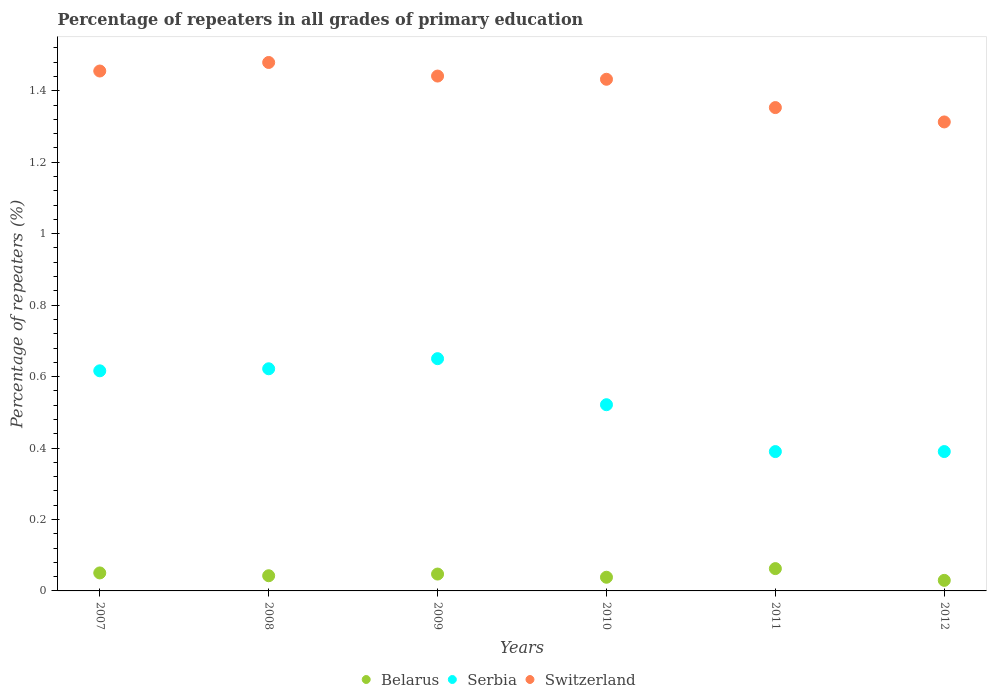Is the number of dotlines equal to the number of legend labels?
Ensure brevity in your answer.  Yes. What is the percentage of repeaters in Belarus in 2008?
Make the answer very short. 0.04. Across all years, what is the maximum percentage of repeaters in Switzerland?
Offer a very short reply. 1.48. Across all years, what is the minimum percentage of repeaters in Serbia?
Your response must be concise. 0.39. In which year was the percentage of repeaters in Serbia minimum?
Give a very brief answer. 2011. What is the total percentage of repeaters in Serbia in the graph?
Ensure brevity in your answer.  3.19. What is the difference between the percentage of repeaters in Serbia in 2009 and that in 2010?
Offer a very short reply. 0.13. What is the difference between the percentage of repeaters in Switzerland in 2009 and the percentage of repeaters in Serbia in 2008?
Offer a very short reply. 0.82. What is the average percentage of repeaters in Switzerland per year?
Ensure brevity in your answer.  1.41. In the year 2007, what is the difference between the percentage of repeaters in Serbia and percentage of repeaters in Belarus?
Provide a succinct answer. 0.57. What is the ratio of the percentage of repeaters in Belarus in 2009 to that in 2010?
Your answer should be compact. 1.23. What is the difference between the highest and the second highest percentage of repeaters in Switzerland?
Your answer should be very brief. 0.02. What is the difference between the highest and the lowest percentage of repeaters in Belarus?
Your response must be concise. 0.03. In how many years, is the percentage of repeaters in Belarus greater than the average percentage of repeaters in Belarus taken over all years?
Your response must be concise. 3. Is the sum of the percentage of repeaters in Switzerland in 2008 and 2010 greater than the maximum percentage of repeaters in Serbia across all years?
Give a very brief answer. Yes. How many dotlines are there?
Provide a short and direct response. 3. Does the graph contain grids?
Give a very brief answer. No. How many legend labels are there?
Your answer should be very brief. 3. What is the title of the graph?
Provide a succinct answer. Percentage of repeaters in all grades of primary education. Does "Azerbaijan" appear as one of the legend labels in the graph?
Provide a short and direct response. No. What is the label or title of the Y-axis?
Give a very brief answer. Percentage of repeaters (%). What is the Percentage of repeaters (%) in Belarus in 2007?
Give a very brief answer. 0.05. What is the Percentage of repeaters (%) in Serbia in 2007?
Ensure brevity in your answer.  0.62. What is the Percentage of repeaters (%) of Switzerland in 2007?
Provide a succinct answer. 1.46. What is the Percentage of repeaters (%) in Belarus in 2008?
Ensure brevity in your answer.  0.04. What is the Percentage of repeaters (%) of Serbia in 2008?
Provide a succinct answer. 0.62. What is the Percentage of repeaters (%) in Switzerland in 2008?
Your answer should be compact. 1.48. What is the Percentage of repeaters (%) of Belarus in 2009?
Provide a succinct answer. 0.05. What is the Percentage of repeaters (%) of Serbia in 2009?
Keep it short and to the point. 0.65. What is the Percentage of repeaters (%) in Switzerland in 2009?
Your answer should be very brief. 1.44. What is the Percentage of repeaters (%) of Belarus in 2010?
Your answer should be compact. 0.04. What is the Percentage of repeaters (%) of Serbia in 2010?
Keep it short and to the point. 0.52. What is the Percentage of repeaters (%) of Switzerland in 2010?
Offer a terse response. 1.43. What is the Percentage of repeaters (%) of Belarus in 2011?
Provide a succinct answer. 0.06. What is the Percentage of repeaters (%) of Serbia in 2011?
Your answer should be compact. 0.39. What is the Percentage of repeaters (%) in Switzerland in 2011?
Provide a succinct answer. 1.35. What is the Percentage of repeaters (%) in Belarus in 2012?
Ensure brevity in your answer.  0.03. What is the Percentage of repeaters (%) in Serbia in 2012?
Your answer should be very brief. 0.39. What is the Percentage of repeaters (%) in Switzerland in 2012?
Your answer should be very brief. 1.31. Across all years, what is the maximum Percentage of repeaters (%) of Belarus?
Your response must be concise. 0.06. Across all years, what is the maximum Percentage of repeaters (%) of Serbia?
Your answer should be compact. 0.65. Across all years, what is the maximum Percentage of repeaters (%) in Switzerland?
Your response must be concise. 1.48. Across all years, what is the minimum Percentage of repeaters (%) of Belarus?
Your response must be concise. 0.03. Across all years, what is the minimum Percentage of repeaters (%) of Serbia?
Make the answer very short. 0.39. Across all years, what is the minimum Percentage of repeaters (%) in Switzerland?
Your answer should be very brief. 1.31. What is the total Percentage of repeaters (%) of Belarus in the graph?
Provide a short and direct response. 0.27. What is the total Percentage of repeaters (%) of Serbia in the graph?
Offer a very short reply. 3.19. What is the total Percentage of repeaters (%) of Switzerland in the graph?
Your answer should be very brief. 8.47. What is the difference between the Percentage of repeaters (%) of Belarus in 2007 and that in 2008?
Your response must be concise. 0.01. What is the difference between the Percentage of repeaters (%) in Serbia in 2007 and that in 2008?
Give a very brief answer. -0.01. What is the difference between the Percentage of repeaters (%) of Switzerland in 2007 and that in 2008?
Provide a succinct answer. -0.02. What is the difference between the Percentage of repeaters (%) in Belarus in 2007 and that in 2009?
Make the answer very short. 0. What is the difference between the Percentage of repeaters (%) of Serbia in 2007 and that in 2009?
Make the answer very short. -0.03. What is the difference between the Percentage of repeaters (%) in Switzerland in 2007 and that in 2009?
Give a very brief answer. 0.01. What is the difference between the Percentage of repeaters (%) of Belarus in 2007 and that in 2010?
Provide a short and direct response. 0.01. What is the difference between the Percentage of repeaters (%) of Serbia in 2007 and that in 2010?
Your answer should be compact. 0.09. What is the difference between the Percentage of repeaters (%) of Switzerland in 2007 and that in 2010?
Give a very brief answer. 0.02. What is the difference between the Percentage of repeaters (%) of Belarus in 2007 and that in 2011?
Ensure brevity in your answer.  -0.01. What is the difference between the Percentage of repeaters (%) of Serbia in 2007 and that in 2011?
Keep it short and to the point. 0.23. What is the difference between the Percentage of repeaters (%) of Switzerland in 2007 and that in 2011?
Provide a succinct answer. 0.1. What is the difference between the Percentage of repeaters (%) of Belarus in 2007 and that in 2012?
Give a very brief answer. 0.02. What is the difference between the Percentage of repeaters (%) of Serbia in 2007 and that in 2012?
Keep it short and to the point. 0.23. What is the difference between the Percentage of repeaters (%) of Switzerland in 2007 and that in 2012?
Your answer should be very brief. 0.14. What is the difference between the Percentage of repeaters (%) of Belarus in 2008 and that in 2009?
Provide a short and direct response. -0. What is the difference between the Percentage of repeaters (%) of Serbia in 2008 and that in 2009?
Give a very brief answer. -0.03. What is the difference between the Percentage of repeaters (%) in Switzerland in 2008 and that in 2009?
Your answer should be very brief. 0.04. What is the difference between the Percentage of repeaters (%) of Belarus in 2008 and that in 2010?
Your response must be concise. 0. What is the difference between the Percentage of repeaters (%) of Serbia in 2008 and that in 2010?
Keep it short and to the point. 0.1. What is the difference between the Percentage of repeaters (%) in Switzerland in 2008 and that in 2010?
Ensure brevity in your answer.  0.05. What is the difference between the Percentage of repeaters (%) in Belarus in 2008 and that in 2011?
Offer a terse response. -0.02. What is the difference between the Percentage of repeaters (%) in Serbia in 2008 and that in 2011?
Provide a succinct answer. 0.23. What is the difference between the Percentage of repeaters (%) in Switzerland in 2008 and that in 2011?
Give a very brief answer. 0.13. What is the difference between the Percentage of repeaters (%) in Belarus in 2008 and that in 2012?
Provide a short and direct response. 0.01. What is the difference between the Percentage of repeaters (%) in Serbia in 2008 and that in 2012?
Provide a succinct answer. 0.23. What is the difference between the Percentage of repeaters (%) in Switzerland in 2008 and that in 2012?
Your response must be concise. 0.17. What is the difference between the Percentage of repeaters (%) in Belarus in 2009 and that in 2010?
Provide a short and direct response. 0.01. What is the difference between the Percentage of repeaters (%) in Serbia in 2009 and that in 2010?
Your answer should be very brief. 0.13. What is the difference between the Percentage of repeaters (%) in Switzerland in 2009 and that in 2010?
Keep it short and to the point. 0.01. What is the difference between the Percentage of repeaters (%) of Belarus in 2009 and that in 2011?
Provide a succinct answer. -0.02. What is the difference between the Percentage of repeaters (%) of Serbia in 2009 and that in 2011?
Your response must be concise. 0.26. What is the difference between the Percentage of repeaters (%) in Switzerland in 2009 and that in 2011?
Give a very brief answer. 0.09. What is the difference between the Percentage of repeaters (%) of Belarus in 2009 and that in 2012?
Ensure brevity in your answer.  0.02. What is the difference between the Percentage of repeaters (%) in Serbia in 2009 and that in 2012?
Provide a succinct answer. 0.26. What is the difference between the Percentage of repeaters (%) of Switzerland in 2009 and that in 2012?
Your answer should be compact. 0.13. What is the difference between the Percentage of repeaters (%) in Belarus in 2010 and that in 2011?
Offer a very short reply. -0.02. What is the difference between the Percentage of repeaters (%) in Serbia in 2010 and that in 2011?
Offer a terse response. 0.13. What is the difference between the Percentage of repeaters (%) in Switzerland in 2010 and that in 2011?
Your answer should be compact. 0.08. What is the difference between the Percentage of repeaters (%) in Belarus in 2010 and that in 2012?
Make the answer very short. 0.01. What is the difference between the Percentage of repeaters (%) of Serbia in 2010 and that in 2012?
Your response must be concise. 0.13. What is the difference between the Percentage of repeaters (%) of Switzerland in 2010 and that in 2012?
Offer a very short reply. 0.12. What is the difference between the Percentage of repeaters (%) in Belarus in 2011 and that in 2012?
Offer a very short reply. 0.03. What is the difference between the Percentage of repeaters (%) of Serbia in 2011 and that in 2012?
Your answer should be compact. -0. What is the difference between the Percentage of repeaters (%) of Switzerland in 2011 and that in 2012?
Ensure brevity in your answer.  0.04. What is the difference between the Percentage of repeaters (%) in Belarus in 2007 and the Percentage of repeaters (%) in Serbia in 2008?
Your answer should be very brief. -0.57. What is the difference between the Percentage of repeaters (%) in Belarus in 2007 and the Percentage of repeaters (%) in Switzerland in 2008?
Keep it short and to the point. -1.43. What is the difference between the Percentage of repeaters (%) of Serbia in 2007 and the Percentage of repeaters (%) of Switzerland in 2008?
Offer a terse response. -0.86. What is the difference between the Percentage of repeaters (%) of Belarus in 2007 and the Percentage of repeaters (%) of Serbia in 2009?
Offer a very short reply. -0.6. What is the difference between the Percentage of repeaters (%) of Belarus in 2007 and the Percentage of repeaters (%) of Switzerland in 2009?
Provide a short and direct response. -1.39. What is the difference between the Percentage of repeaters (%) of Serbia in 2007 and the Percentage of repeaters (%) of Switzerland in 2009?
Your answer should be very brief. -0.83. What is the difference between the Percentage of repeaters (%) of Belarus in 2007 and the Percentage of repeaters (%) of Serbia in 2010?
Your answer should be compact. -0.47. What is the difference between the Percentage of repeaters (%) of Belarus in 2007 and the Percentage of repeaters (%) of Switzerland in 2010?
Your answer should be very brief. -1.38. What is the difference between the Percentage of repeaters (%) in Serbia in 2007 and the Percentage of repeaters (%) in Switzerland in 2010?
Your answer should be very brief. -0.82. What is the difference between the Percentage of repeaters (%) in Belarus in 2007 and the Percentage of repeaters (%) in Serbia in 2011?
Your response must be concise. -0.34. What is the difference between the Percentage of repeaters (%) of Belarus in 2007 and the Percentage of repeaters (%) of Switzerland in 2011?
Your answer should be compact. -1.3. What is the difference between the Percentage of repeaters (%) in Serbia in 2007 and the Percentage of repeaters (%) in Switzerland in 2011?
Your answer should be compact. -0.74. What is the difference between the Percentage of repeaters (%) in Belarus in 2007 and the Percentage of repeaters (%) in Serbia in 2012?
Offer a terse response. -0.34. What is the difference between the Percentage of repeaters (%) in Belarus in 2007 and the Percentage of repeaters (%) in Switzerland in 2012?
Ensure brevity in your answer.  -1.26. What is the difference between the Percentage of repeaters (%) in Serbia in 2007 and the Percentage of repeaters (%) in Switzerland in 2012?
Offer a terse response. -0.7. What is the difference between the Percentage of repeaters (%) of Belarus in 2008 and the Percentage of repeaters (%) of Serbia in 2009?
Keep it short and to the point. -0.61. What is the difference between the Percentage of repeaters (%) in Belarus in 2008 and the Percentage of repeaters (%) in Switzerland in 2009?
Ensure brevity in your answer.  -1.4. What is the difference between the Percentage of repeaters (%) in Serbia in 2008 and the Percentage of repeaters (%) in Switzerland in 2009?
Your answer should be compact. -0.82. What is the difference between the Percentage of repeaters (%) in Belarus in 2008 and the Percentage of repeaters (%) in Serbia in 2010?
Give a very brief answer. -0.48. What is the difference between the Percentage of repeaters (%) in Belarus in 2008 and the Percentage of repeaters (%) in Switzerland in 2010?
Offer a very short reply. -1.39. What is the difference between the Percentage of repeaters (%) in Serbia in 2008 and the Percentage of repeaters (%) in Switzerland in 2010?
Your answer should be very brief. -0.81. What is the difference between the Percentage of repeaters (%) in Belarus in 2008 and the Percentage of repeaters (%) in Serbia in 2011?
Your response must be concise. -0.35. What is the difference between the Percentage of repeaters (%) in Belarus in 2008 and the Percentage of repeaters (%) in Switzerland in 2011?
Offer a terse response. -1.31. What is the difference between the Percentage of repeaters (%) of Serbia in 2008 and the Percentage of repeaters (%) of Switzerland in 2011?
Make the answer very short. -0.73. What is the difference between the Percentage of repeaters (%) in Belarus in 2008 and the Percentage of repeaters (%) in Serbia in 2012?
Provide a succinct answer. -0.35. What is the difference between the Percentage of repeaters (%) of Belarus in 2008 and the Percentage of repeaters (%) of Switzerland in 2012?
Keep it short and to the point. -1.27. What is the difference between the Percentage of repeaters (%) of Serbia in 2008 and the Percentage of repeaters (%) of Switzerland in 2012?
Provide a succinct answer. -0.69. What is the difference between the Percentage of repeaters (%) in Belarus in 2009 and the Percentage of repeaters (%) in Serbia in 2010?
Make the answer very short. -0.47. What is the difference between the Percentage of repeaters (%) in Belarus in 2009 and the Percentage of repeaters (%) in Switzerland in 2010?
Make the answer very short. -1.39. What is the difference between the Percentage of repeaters (%) of Serbia in 2009 and the Percentage of repeaters (%) of Switzerland in 2010?
Your answer should be very brief. -0.78. What is the difference between the Percentage of repeaters (%) of Belarus in 2009 and the Percentage of repeaters (%) of Serbia in 2011?
Keep it short and to the point. -0.34. What is the difference between the Percentage of repeaters (%) in Belarus in 2009 and the Percentage of repeaters (%) in Switzerland in 2011?
Your response must be concise. -1.31. What is the difference between the Percentage of repeaters (%) in Serbia in 2009 and the Percentage of repeaters (%) in Switzerland in 2011?
Provide a short and direct response. -0.7. What is the difference between the Percentage of repeaters (%) in Belarus in 2009 and the Percentage of repeaters (%) in Serbia in 2012?
Provide a succinct answer. -0.34. What is the difference between the Percentage of repeaters (%) in Belarus in 2009 and the Percentage of repeaters (%) in Switzerland in 2012?
Give a very brief answer. -1.27. What is the difference between the Percentage of repeaters (%) in Serbia in 2009 and the Percentage of repeaters (%) in Switzerland in 2012?
Make the answer very short. -0.66. What is the difference between the Percentage of repeaters (%) of Belarus in 2010 and the Percentage of repeaters (%) of Serbia in 2011?
Make the answer very short. -0.35. What is the difference between the Percentage of repeaters (%) in Belarus in 2010 and the Percentage of repeaters (%) in Switzerland in 2011?
Give a very brief answer. -1.31. What is the difference between the Percentage of repeaters (%) in Serbia in 2010 and the Percentage of repeaters (%) in Switzerland in 2011?
Give a very brief answer. -0.83. What is the difference between the Percentage of repeaters (%) of Belarus in 2010 and the Percentage of repeaters (%) of Serbia in 2012?
Offer a terse response. -0.35. What is the difference between the Percentage of repeaters (%) of Belarus in 2010 and the Percentage of repeaters (%) of Switzerland in 2012?
Offer a terse response. -1.27. What is the difference between the Percentage of repeaters (%) in Serbia in 2010 and the Percentage of repeaters (%) in Switzerland in 2012?
Make the answer very short. -0.79. What is the difference between the Percentage of repeaters (%) in Belarus in 2011 and the Percentage of repeaters (%) in Serbia in 2012?
Make the answer very short. -0.33. What is the difference between the Percentage of repeaters (%) in Belarus in 2011 and the Percentage of repeaters (%) in Switzerland in 2012?
Your response must be concise. -1.25. What is the difference between the Percentage of repeaters (%) in Serbia in 2011 and the Percentage of repeaters (%) in Switzerland in 2012?
Give a very brief answer. -0.92. What is the average Percentage of repeaters (%) in Belarus per year?
Provide a succinct answer. 0.05. What is the average Percentage of repeaters (%) in Serbia per year?
Give a very brief answer. 0.53. What is the average Percentage of repeaters (%) in Switzerland per year?
Keep it short and to the point. 1.41. In the year 2007, what is the difference between the Percentage of repeaters (%) in Belarus and Percentage of repeaters (%) in Serbia?
Your response must be concise. -0.57. In the year 2007, what is the difference between the Percentage of repeaters (%) in Belarus and Percentage of repeaters (%) in Switzerland?
Your answer should be compact. -1.41. In the year 2007, what is the difference between the Percentage of repeaters (%) in Serbia and Percentage of repeaters (%) in Switzerland?
Your answer should be compact. -0.84. In the year 2008, what is the difference between the Percentage of repeaters (%) in Belarus and Percentage of repeaters (%) in Serbia?
Ensure brevity in your answer.  -0.58. In the year 2008, what is the difference between the Percentage of repeaters (%) in Belarus and Percentage of repeaters (%) in Switzerland?
Your answer should be very brief. -1.44. In the year 2008, what is the difference between the Percentage of repeaters (%) in Serbia and Percentage of repeaters (%) in Switzerland?
Provide a succinct answer. -0.86. In the year 2009, what is the difference between the Percentage of repeaters (%) in Belarus and Percentage of repeaters (%) in Serbia?
Offer a very short reply. -0.6. In the year 2009, what is the difference between the Percentage of repeaters (%) in Belarus and Percentage of repeaters (%) in Switzerland?
Your answer should be compact. -1.39. In the year 2009, what is the difference between the Percentage of repeaters (%) of Serbia and Percentage of repeaters (%) of Switzerland?
Provide a short and direct response. -0.79. In the year 2010, what is the difference between the Percentage of repeaters (%) in Belarus and Percentage of repeaters (%) in Serbia?
Offer a very short reply. -0.48. In the year 2010, what is the difference between the Percentage of repeaters (%) in Belarus and Percentage of repeaters (%) in Switzerland?
Provide a short and direct response. -1.39. In the year 2010, what is the difference between the Percentage of repeaters (%) in Serbia and Percentage of repeaters (%) in Switzerland?
Give a very brief answer. -0.91. In the year 2011, what is the difference between the Percentage of repeaters (%) of Belarus and Percentage of repeaters (%) of Serbia?
Provide a succinct answer. -0.33. In the year 2011, what is the difference between the Percentage of repeaters (%) in Belarus and Percentage of repeaters (%) in Switzerland?
Your answer should be very brief. -1.29. In the year 2011, what is the difference between the Percentage of repeaters (%) of Serbia and Percentage of repeaters (%) of Switzerland?
Ensure brevity in your answer.  -0.96. In the year 2012, what is the difference between the Percentage of repeaters (%) in Belarus and Percentage of repeaters (%) in Serbia?
Offer a very short reply. -0.36. In the year 2012, what is the difference between the Percentage of repeaters (%) of Belarus and Percentage of repeaters (%) of Switzerland?
Your answer should be very brief. -1.28. In the year 2012, what is the difference between the Percentage of repeaters (%) of Serbia and Percentage of repeaters (%) of Switzerland?
Provide a succinct answer. -0.92. What is the ratio of the Percentage of repeaters (%) in Belarus in 2007 to that in 2008?
Your response must be concise. 1.18. What is the ratio of the Percentage of repeaters (%) in Switzerland in 2007 to that in 2008?
Provide a succinct answer. 0.98. What is the ratio of the Percentage of repeaters (%) in Belarus in 2007 to that in 2009?
Ensure brevity in your answer.  1.07. What is the ratio of the Percentage of repeaters (%) in Serbia in 2007 to that in 2009?
Provide a short and direct response. 0.95. What is the ratio of the Percentage of repeaters (%) of Switzerland in 2007 to that in 2009?
Provide a succinct answer. 1.01. What is the ratio of the Percentage of repeaters (%) in Belarus in 2007 to that in 2010?
Your answer should be very brief. 1.31. What is the ratio of the Percentage of repeaters (%) in Serbia in 2007 to that in 2010?
Offer a very short reply. 1.18. What is the ratio of the Percentage of repeaters (%) in Switzerland in 2007 to that in 2010?
Keep it short and to the point. 1.02. What is the ratio of the Percentage of repeaters (%) in Belarus in 2007 to that in 2011?
Offer a terse response. 0.81. What is the ratio of the Percentage of repeaters (%) of Serbia in 2007 to that in 2011?
Your answer should be very brief. 1.58. What is the ratio of the Percentage of repeaters (%) in Switzerland in 2007 to that in 2011?
Your answer should be compact. 1.08. What is the ratio of the Percentage of repeaters (%) of Belarus in 2007 to that in 2012?
Your response must be concise. 1.7. What is the ratio of the Percentage of repeaters (%) of Serbia in 2007 to that in 2012?
Offer a terse response. 1.58. What is the ratio of the Percentage of repeaters (%) in Switzerland in 2007 to that in 2012?
Give a very brief answer. 1.11. What is the ratio of the Percentage of repeaters (%) in Belarus in 2008 to that in 2009?
Give a very brief answer. 0.9. What is the ratio of the Percentage of repeaters (%) of Serbia in 2008 to that in 2009?
Your answer should be very brief. 0.96. What is the ratio of the Percentage of repeaters (%) in Switzerland in 2008 to that in 2009?
Your response must be concise. 1.03. What is the ratio of the Percentage of repeaters (%) in Belarus in 2008 to that in 2010?
Your answer should be very brief. 1.11. What is the ratio of the Percentage of repeaters (%) of Serbia in 2008 to that in 2010?
Your response must be concise. 1.19. What is the ratio of the Percentage of repeaters (%) in Switzerland in 2008 to that in 2010?
Provide a short and direct response. 1.03. What is the ratio of the Percentage of repeaters (%) of Belarus in 2008 to that in 2011?
Your answer should be compact. 0.68. What is the ratio of the Percentage of repeaters (%) in Serbia in 2008 to that in 2011?
Keep it short and to the point. 1.59. What is the ratio of the Percentage of repeaters (%) of Switzerland in 2008 to that in 2011?
Offer a terse response. 1.09. What is the ratio of the Percentage of repeaters (%) of Belarus in 2008 to that in 2012?
Your answer should be very brief. 1.44. What is the ratio of the Percentage of repeaters (%) in Serbia in 2008 to that in 2012?
Provide a succinct answer. 1.59. What is the ratio of the Percentage of repeaters (%) in Switzerland in 2008 to that in 2012?
Your answer should be compact. 1.13. What is the ratio of the Percentage of repeaters (%) of Belarus in 2009 to that in 2010?
Your answer should be compact. 1.23. What is the ratio of the Percentage of repeaters (%) of Serbia in 2009 to that in 2010?
Provide a short and direct response. 1.25. What is the ratio of the Percentage of repeaters (%) of Switzerland in 2009 to that in 2010?
Your answer should be very brief. 1.01. What is the ratio of the Percentage of repeaters (%) of Belarus in 2009 to that in 2011?
Make the answer very short. 0.76. What is the ratio of the Percentage of repeaters (%) in Serbia in 2009 to that in 2011?
Provide a succinct answer. 1.67. What is the ratio of the Percentage of repeaters (%) of Switzerland in 2009 to that in 2011?
Offer a terse response. 1.07. What is the ratio of the Percentage of repeaters (%) in Belarus in 2009 to that in 2012?
Ensure brevity in your answer.  1.6. What is the ratio of the Percentage of repeaters (%) of Serbia in 2009 to that in 2012?
Your answer should be compact. 1.67. What is the ratio of the Percentage of repeaters (%) in Switzerland in 2009 to that in 2012?
Your answer should be compact. 1.1. What is the ratio of the Percentage of repeaters (%) in Belarus in 2010 to that in 2011?
Give a very brief answer. 0.61. What is the ratio of the Percentage of repeaters (%) in Serbia in 2010 to that in 2011?
Provide a succinct answer. 1.34. What is the ratio of the Percentage of repeaters (%) in Switzerland in 2010 to that in 2011?
Your answer should be compact. 1.06. What is the ratio of the Percentage of repeaters (%) in Belarus in 2010 to that in 2012?
Give a very brief answer. 1.3. What is the ratio of the Percentage of repeaters (%) of Serbia in 2010 to that in 2012?
Ensure brevity in your answer.  1.34. What is the ratio of the Percentage of repeaters (%) in Switzerland in 2010 to that in 2012?
Give a very brief answer. 1.09. What is the ratio of the Percentage of repeaters (%) of Belarus in 2011 to that in 2012?
Your answer should be very brief. 2.11. What is the ratio of the Percentage of repeaters (%) in Switzerland in 2011 to that in 2012?
Provide a succinct answer. 1.03. What is the difference between the highest and the second highest Percentage of repeaters (%) of Belarus?
Offer a terse response. 0.01. What is the difference between the highest and the second highest Percentage of repeaters (%) in Serbia?
Offer a terse response. 0.03. What is the difference between the highest and the second highest Percentage of repeaters (%) of Switzerland?
Make the answer very short. 0.02. What is the difference between the highest and the lowest Percentage of repeaters (%) in Belarus?
Keep it short and to the point. 0.03. What is the difference between the highest and the lowest Percentage of repeaters (%) in Serbia?
Give a very brief answer. 0.26. What is the difference between the highest and the lowest Percentage of repeaters (%) of Switzerland?
Offer a very short reply. 0.17. 